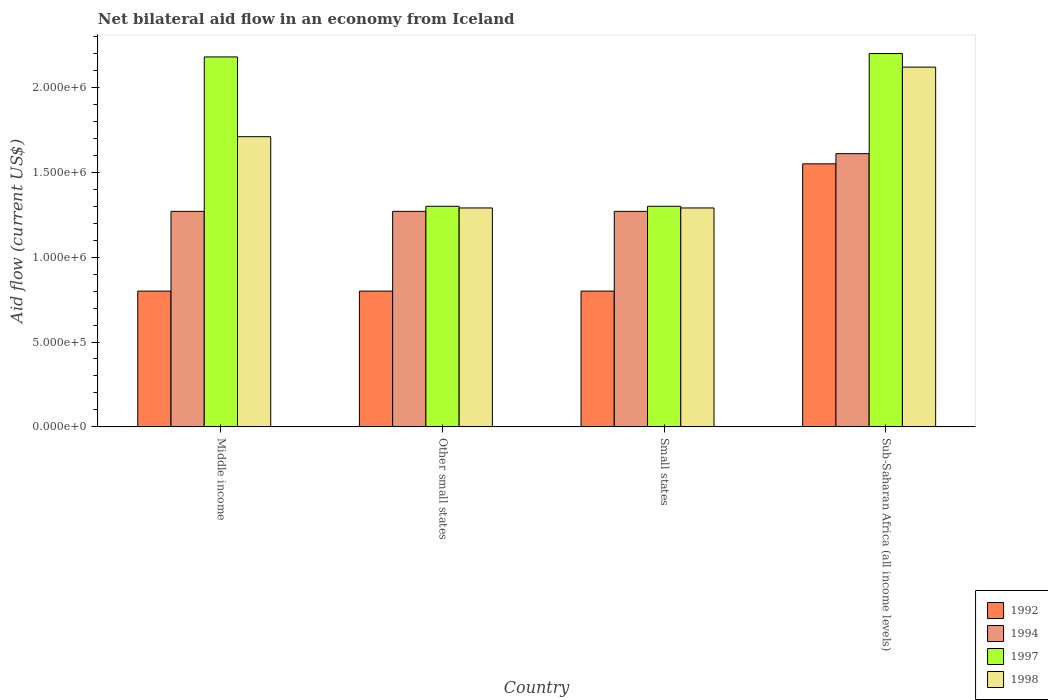How many groups of bars are there?
Give a very brief answer. 4. Are the number of bars per tick equal to the number of legend labels?
Provide a short and direct response. Yes. Are the number of bars on each tick of the X-axis equal?
Provide a succinct answer. Yes. What is the label of the 4th group of bars from the left?
Make the answer very short. Sub-Saharan Africa (all income levels). What is the net bilateral aid flow in 1994 in Small states?
Your response must be concise. 1.27e+06. Across all countries, what is the maximum net bilateral aid flow in 1994?
Your answer should be compact. 1.61e+06. Across all countries, what is the minimum net bilateral aid flow in 1997?
Provide a succinct answer. 1.30e+06. In which country was the net bilateral aid flow in 1998 maximum?
Ensure brevity in your answer.  Sub-Saharan Africa (all income levels). In which country was the net bilateral aid flow in 1994 minimum?
Offer a terse response. Middle income. What is the total net bilateral aid flow in 1994 in the graph?
Offer a very short reply. 5.42e+06. What is the difference between the net bilateral aid flow in 1994 in Middle income and that in Other small states?
Offer a terse response. 0. What is the difference between the net bilateral aid flow in 1998 in Other small states and the net bilateral aid flow in 1994 in Middle income?
Make the answer very short. 2.00e+04. What is the average net bilateral aid flow in 1992 per country?
Keep it short and to the point. 9.88e+05. What is the difference between the net bilateral aid flow of/in 1997 and net bilateral aid flow of/in 1998 in Small states?
Provide a short and direct response. 10000. What is the ratio of the net bilateral aid flow in 1994 in Middle income to that in Small states?
Provide a short and direct response. 1. What is the difference between the highest and the lowest net bilateral aid flow in 1998?
Your response must be concise. 8.30e+05. In how many countries, is the net bilateral aid flow in 1997 greater than the average net bilateral aid flow in 1997 taken over all countries?
Keep it short and to the point. 2. Is the sum of the net bilateral aid flow in 1998 in Small states and Sub-Saharan Africa (all income levels) greater than the maximum net bilateral aid flow in 1997 across all countries?
Offer a very short reply. Yes. What does the 4th bar from the right in Small states represents?
Your answer should be very brief. 1992. Is it the case that in every country, the sum of the net bilateral aid flow in 1997 and net bilateral aid flow in 1994 is greater than the net bilateral aid flow in 1998?
Provide a succinct answer. Yes. How many bars are there?
Keep it short and to the point. 16. Are all the bars in the graph horizontal?
Your answer should be compact. No. Does the graph contain grids?
Ensure brevity in your answer.  No. Where does the legend appear in the graph?
Your answer should be very brief. Bottom right. How are the legend labels stacked?
Provide a succinct answer. Vertical. What is the title of the graph?
Provide a short and direct response. Net bilateral aid flow in an economy from Iceland. What is the Aid flow (current US$) of 1992 in Middle income?
Make the answer very short. 8.00e+05. What is the Aid flow (current US$) of 1994 in Middle income?
Keep it short and to the point. 1.27e+06. What is the Aid flow (current US$) in 1997 in Middle income?
Keep it short and to the point. 2.18e+06. What is the Aid flow (current US$) of 1998 in Middle income?
Provide a short and direct response. 1.71e+06. What is the Aid flow (current US$) of 1992 in Other small states?
Provide a short and direct response. 8.00e+05. What is the Aid flow (current US$) in 1994 in Other small states?
Your response must be concise. 1.27e+06. What is the Aid flow (current US$) of 1997 in Other small states?
Give a very brief answer. 1.30e+06. What is the Aid flow (current US$) in 1998 in Other small states?
Make the answer very short. 1.29e+06. What is the Aid flow (current US$) in 1994 in Small states?
Your response must be concise. 1.27e+06. What is the Aid flow (current US$) of 1997 in Small states?
Give a very brief answer. 1.30e+06. What is the Aid flow (current US$) in 1998 in Small states?
Give a very brief answer. 1.29e+06. What is the Aid flow (current US$) of 1992 in Sub-Saharan Africa (all income levels)?
Your answer should be very brief. 1.55e+06. What is the Aid flow (current US$) of 1994 in Sub-Saharan Africa (all income levels)?
Make the answer very short. 1.61e+06. What is the Aid flow (current US$) in 1997 in Sub-Saharan Africa (all income levels)?
Offer a very short reply. 2.20e+06. What is the Aid flow (current US$) in 1998 in Sub-Saharan Africa (all income levels)?
Your response must be concise. 2.12e+06. Across all countries, what is the maximum Aid flow (current US$) of 1992?
Your answer should be compact. 1.55e+06. Across all countries, what is the maximum Aid flow (current US$) in 1994?
Provide a short and direct response. 1.61e+06. Across all countries, what is the maximum Aid flow (current US$) of 1997?
Your answer should be very brief. 2.20e+06. Across all countries, what is the maximum Aid flow (current US$) of 1998?
Keep it short and to the point. 2.12e+06. Across all countries, what is the minimum Aid flow (current US$) of 1992?
Offer a terse response. 8.00e+05. Across all countries, what is the minimum Aid flow (current US$) of 1994?
Provide a short and direct response. 1.27e+06. Across all countries, what is the minimum Aid flow (current US$) in 1997?
Provide a succinct answer. 1.30e+06. Across all countries, what is the minimum Aid flow (current US$) in 1998?
Your answer should be very brief. 1.29e+06. What is the total Aid flow (current US$) of 1992 in the graph?
Ensure brevity in your answer.  3.95e+06. What is the total Aid flow (current US$) in 1994 in the graph?
Provide a succinct answer. 5.42e+06. What is the total Aid flow (current US$) in 1997 in the graph?
Provide a succinct answer. 6.98e+06. What is the total Aid flow (current US$) of 1998 in the graph?
Offer a terse response. 6.41e+06. What is the difference between the Aid flow (current US$) of 1992 in Middle income and that in Other small states?
Offer a terse response. 0. What is the difference between the Aid flow (current US$) of 1994 in Middle income and that in Other small states?
Your answer should be compact. 0. What is the difference between the Aid flow (current US$) of 1997 in Middle income and that in Other small states?
Ensure brevity in your answer.  8.80e+05. What is the difference between the Aid flow (current US$) of 1994 in Middle income and that in Small states?
Provide a short and direct response. 0. What is the difference between the Aid flow (current US$) in 1997 in Middle income and that in Small states?
Your response must be concise. 8.80e+05. What is the difference between the Aid flow (current US$) in 1998 in Middle income and that in Small states?
Ensure brevity in your answer.  4.20e+05. What is the difference between the Aid flow (current US$) in 1992 in Middle income and that in Sub-Saharan Africa (all income levels)?
Ensure brevity in your answer.  -7.50e+05. What is the difference between the Aid flow (current US$) of 1997 in Middle income and that in Sub-Saharan Africa (all income levels)?
Offer a very short reply. -2.00e+04. What is the difference between the Aid flow (current US$) in 1998 in Middle income and that in Sub-Saharan Africa (all income levels)?
Offer a terse response. -4.10e+05. What is the difference between the Aid flow (current US$) in 1992 in Other small states and that in Small states?
Your answer should be compact. 0. What is the difference between the Aid flow (current US$) of 1994 in Other small states and that in Small states?
Keep it short and to the point. 0. What is the difference between the Aid flow (current US$) of 1998 in Other small states and that in Small states?
Make the answer very short. 0. What is the difference between the Aid flow (current US$) of 1992 in Other small states and that in Sub-Saharan Africa (all income levels)?
Provide a short and direct response. -7.50e+05. What is the difference between the Aid flow (current US$) in 1997 in Other small states and that in Sub-Saharan Africa (all income levels)?
Your answer should be compact. -9.00e+05. What is the difference between the Aid flow (current US$) in 1998 in Other small states and that in Sub-Saharan Africa (all income levels)?
Give a very brief answer. -8.30e+05. What is the difference between the Aid flow (current US$) of 1992 in Small states and that in Sub-Saharan Africa (all income levels)?
Give a very brief answer. -7.50e+05. What is the difference between the Aid flow (current US$) of 1994 in Small states and that in Sub-Saharan Africa (all income levels)?
Provide a succinct answer. -3.40e+05. What is the difference between the Aid flow (current US$) of 1997 in Small states and that in Sub-Saharan Africa (all income levels)?
Provide a succinct answer. -9.00e+05. What is the difference between the Aid flow (current US$) in 1998 in Small states and that in Sub-Saharan Africa (all income levels)?
Your answer should be very brief. -8.30e+05. What is the difference between the Aid flow (current US$) in 1992 in Middle income and the Aid flow (current US$) in 1994 in Other small states?
Ensure brevity in your answer.  -4.70e+05. What is the difference between the Aid flow (current US$) of 1992 in Middle income and the Aid flow (current US$) of 1997 in Other small states?
Ensure brevity in your answer.  -5.00e+05. What is the difference between the Aid flow (current US$) of 1992 in Middle income and the Aid flow (current US$) of 1998 in Other small states?
Give a very brief answer. -4.90e+05. What is the difference between the Aid flow (current US$) in 1994 in Middle income and the Aid flow (current US$) in 1998 in Other small states?
Provide a succinct answer. -2.00e+04. What is the difference between the Aid flow (current US$) in 1997 in Middle income and the Aid flow (current US$) in 1998 in Other small states?
Keep it short and to the point. 8.90e+05. What is the difference between the Aid flow (current US$) in 1992 in Middle income and the Aid flow (current US$) in 1994 in Small states?
Give a very brief answer. -4.70e+05. What is the difference between the Aid flow (current US$) of 1992 in Middle income and the Aid flow (current US$) of 1997 in Small states?
Keep it short and to the point. -5.00e+05. What is the difference between the Aid flow (current US$) of 1992 in Middle income and the Aid flow (current US$) of 1998 in Small states?
Offer a very short reply. -4.90e+05. What is the difference between the Aid flow (current US$) of 1997 in Middle income and the Aid flow (current US$) of 1998 in Small states?
Your response must be concise. 8.90e+05. What is the difference between the Aid flow (current US$) in 1992 in Middle income and the Aid flow (current US$) in 1994 in Sub-Saharan Africa (all income levels)?
Provide a short and direct response. -8.10e+05. What is the difference between the Aid flow (current US$) in 1992 in Middle income and the Aid flow (current US$) in 1997 in Sub-Saharan Africa (all income levels)?
Your answer should be compact. -1.40e+06. What is the difference between the Aid flow (current US$) of 1992 in Middle income and the Aid flow (current US$) of 1998 in Sub-Saharan Africa (all income levels)?
Ensure brevity in your answer.  -1.32e+06. What is the difference between the Aid flow (current US$) in 1994 in Middle income and the Aid flow (current US$) in 1997 in Sub-Saharan Africa (all income levels)?
Keep it short and to the point. -9.30e+05. What is the difference between the Aid flow (current US$) of 1994 in Middle income and the Aid flow (current US$) of 1998 in Sub-Saharan Africa (all income levels)?
Provide a short and direct response. -8.50e+05. What is the difference between the Aid flow (current US$) of 1992 in Other small states and the Aid flow (current US$) of 1994 in Small states?
Your answer should be compact. -4.70e+05. What is the difference between the Aid flow (current US$) of 1992 in Other small states and the Aid flow (current US$) of 1997 in Small states?
Your response must be concise. -5.00e+05. What is the difference between the Aid flow (current US$) in 1992 in Other small states and the Aid flow (current US$) in 1998 in Small states?
Keep it short and to the point. -4.90e+05. What is the difference between the Aid flow (current US$) of 1994 in Other small states and the Aid flow (current US$) of 1998 in Small states?
Keep it short and to the point. -2.00e+04. What is the difference between the Aid flow (current US$) of 1992 in Other small states and the Aid flow (current US$) of 1994 in Sub-Saharan Africa (all income levels)?
Your answer should be very brief. -8.10e+05. What is the difference between the Aid flow (current US$) in 1992 in Other small states and the Aid flow (current US$) in 1997 in Sub-Saharan Africa (all income levels)?
Your answer should be very brief. -1.40e+06. What is the difference between the Aid flow (current US$) of 1992 in Other small states and the Aid flow (current US$) of 1998 in Sub-Saharan Africa (all income levels)?
Provide a succinct answer. -1.32e+06. What is the difference between the Aid flow (current US$) in 1994 in Other small states and the Aid flow (current US$) in 1997 in Sub-Saharan Africa (all income levels)?
Make the answer very short. -9.30e+05. What is the difference between the Aid flow (current US$) of 1994 in Other small states and the Aid flow (current US$) of 1998 in Sub-Saharan Africa (all income levels)?
Provide a short and direct response. -8.50e+05. What is the difference between the Aid flow (current US$) in 1997 in Other small states and the Aid flow (current US$) in 1998 in Sub-Saharan Africa (all income levels)?
Your answer should be compact. -8.20e+05. What is the difference between the Aid flow (current US$) in 1992 in Small states and the Aid flow (current US$) in 1994 in Sub-Saharan Africa (all income levels)?
Offer a terse response. -8.10e+05. What is the difference between the Aid flow (current US$) of 1992 in Small states and the Aid flow (current US$) of 1997 in Sub-Saharan Africa (all income levels)?
Ensure brevity in your answer.  -1.40e+06. What is the difference between the Aid flow (current US$) of 1992 in Small states and the Aid flow (current US$) of 1998 in Sub-Saharan Africa (all income levels)?
Your answer should be very brief. -1.32e+06. What is the difference between the Aid flow (current US$) in 1994 in Small states and the Aid flow (current US$) in 1997 in Sub-Saharan Africa (all income levels)?
Your answer should be very brief. -9.30e+05. What is the difference between the Aid flow (current US$) in 1994 in Small states and the Aid flow (current US$) in 1998 in Sub-Saharan Africa (all income levels)?
Your answer should be very brief. -8.50e+05. What is the difference between the Aid flow (current US$) of 1997 in Small states and the Aid flow (current US$) of 1998 in Sub-Saharan Africa (all income levels)?
Your response must be concise. -8.20e+05. What is the average Aid flow (current US$) of 1992 per country?
Your answer should be compact. 9.88e+05. What is the average Aid flow (current US$) in 1994 per country?
Your response must be concise. 1.36e+06. What is the average Aid flow (current US$) in 1997 per country?
Your response must be concise. 1.74e+06. What is the average Aid flow (current US$) in 1998 per country?
Make the answer very short. 1.60e+06. What is the difference between the Aid flow (current US$) in 1992 and Aid flow (current US$) in 1994 in Middle income?
Give a very brief answer. -4.70e+05. What is the difference between the Aid flow (current US$) of 1992 and Aid flow (current US$) of 1997 in Middle income?
Offer a terse response. -1.38e+06. What is the difference between the Aid flow (current US$) of 1992 and Aid flow (current US$) of 1998 in Middle income?
Your answer should be compact. -9.10e+05. What is the difference between the Aid flow (current US$) in 1994 and Aid flow (current US$) in 1997 in Middle income?
Your answer should be compact. -9.10e+05. What is the difference between the Aid flow (current US$) of 1994 and Aid flow (current US$) of 1998 in Middle income?
Provide a succinct answer. -4.40e+05. What is the difference between the Aid flow (current US$) of 1992 and Aid flow (current US$) of 1994 in Other small states?
Offer a very short reply. -4.70e+05. What is the difference between the Aid flow (current US$) in 1992 and Aid flow (current US$) in 1997 in Other small states?
Make the answer very short. -5.00e+05. What is the difference between the Aid flow (current US$) of 1992 and Aid flow (current US$) of 1998 in Other small states?
Provide a succinct answer. -4.90e+05. What is the difference between the Aid flow (current US$) in 1994 and Aid flow (current US$) in 1998 in Other small states?
Provide a short and direct response. -2.00e+04. What is the difference between the Aid flow (current US$) in 1992 and Aid flow (current US$) in 1994 in Small states?
Make the answer very short. -4.70e+05. What is the difference between the Aid flow (current US$) of 1992 and Aid flow (current US$) of 1997 in Small states?
Keep it short and to the point. -5.00e+05. What is the difference between the Aid flow (current US$) in 1992 and Aid flow (current US$) in 1998 in Small states?
Give a very brief answer. -4.90e+05. What is the difference between the Aid flow (current US$) of 1994 and Aid flow (current US$) of 1997 in Small states?
Make the answer very short. -3.00e+04. What is the difference between the Aid flow (current US$) of 1997 and Aid flow (current US$) of 1998 in Small states?
Offer a very short reply. 10000. What is the difference between the Aid flow (current US$) in 1992 and Aid flow (current US$) in 1994 in Sub-Saharan Africa (all income levels)?
Ensure brevity in your answer.  -6.00e+04. What is the difference between the Aid flow (current US$) in 1992 and Aid flow (current US$) in 1997 in Sub-Saharan Africa (all income levels)?
Keep it short and to the point. -6.50e+05. What is the difference between the Aid flow (current US$) in 1992 and Aid flow (current US$) in 1998 in Sub-Saharan Africa (all income levels)?
Your response must be concise. -5.70e+05. What is the difference between the Aid flow (current US$) in 1994 and Aid flow (current US$) in 1997 in Sub-Saharan Africa (all income levels)?
Offer a terse response. -5.90e+05. What is the difference between the Aid flow (current US$) of 1994 and Aid flow (current US$) of 1998 in Sub-Saharan Africa (all income levels)?
Your answer should be very brief. -5.10e+05. What is the difference between the Aid flow (current US$) in 1997 and Aid flow (current US$) in 1998 in Sub-Saharan Africa (all income levels)?
Your answer should be compact. 8.00e+04. What is the ratio of the Aid flow (current US$) in 1997 in Middle income to that in Other small states?
Provide a short and direct response. 1.68. What is the ratio of the Aid flow (current US$) in 1998 in Middle income to that in Other small states?
Provide a short and direct response. 1.33. What is the ratio of the Aid flow (current US$) of 1992 in Middle income to that in Small states?
Provide a succinct answer. 1. What is the ratio of the Aid flow (current US$) in 1994 in Middle income to that in Small states?
Ensure brevity in your answer.  1. What is the ratio of the Aid flow (current US$) in 1997 in Middle income to that in Small states?
Offer a very short reply. 1.68. What is the ratio of the Aid flow (current US$) in 1998 in Middle income to that in Small states?
Ensure brevity in your answer.  1.33. What is the ratio of the Aid flow (current US$) in 1992 in Middle income to that in Sub-Saharan Africa (all income levels)?
Keep it short and to the point. 0.52. What is the ratio of the Aid flow (current US$) of 1994 in Middle income to that in Sub-Saharan Africa (all income levels)?
Ensure brevity in your answer.  0.79. What is the ratio of the Aid flow (current US$) of 1997 in Middle income to that in Sub-Saharan Africa (all income levels)?
Your answer should be compact. 0.99. What is the ratio of the Aid flow (current US$) in 1998 in Middle income to that in Sub-Saharan Africa (all income levels)?
Your answer should be compact. 0.81. What is the ratio of the Aid flow (current US$) of 1994 in Other small states to that in Small states?
Provide a short and direct response. 1. What is the ratio of the Aid flow (current US$) of 1997 in Other small states to that in Small states?
Ensure brevity in your answer.  1. What is the ratio of the Aid flow (current US$) of 1998 in Other small states to that in Small states?
Provide a short and direct response. 1. What is the ratio of the Aid flow (current US$) in 1992 in Other small states to that in Sub-Saharan Africa (all income levels)?
Make the answer very short. 0.52. What is the ratio of the Aid flow (current US$) in 1994 in Other small states to that in Sub-Saharan Africa (all income levels)?
Offer a very short reply. 0.79. What is the ratio of the Aid flow (current US$) of 1997 in Other small states to that in Sub-Saharan Africa (all income levels)?
Ensure brevity in your answer.  0.59. What is the ratio of the Aid flow (current US$) in 1998 in Other small states to that in Sub-Saharan Africa (all income levels)?
Your response must be concise. 0.61. What is the ratio of the Aid flow (current US$) of 1992 in Small states to that in Sub-Saharan Africa (all income levels)?
Offer a terse response. 0.52. What is the ratio of the Aid flow (current US$) in 1994 in Small states to that in Sub-Saharan Africa (all income levels)?
Make the answer very short. 0.79. What is the ratio of the Aid flow (current US$) of 1997 in Small states to that in Sub-Saharan Africa (all income levels)?
Provide a succinct answer. 0.59. What is the ratio of the Aid flow (current US$) in 1998 in Small states to that in Sub-Saharan Africa (all income levels)?
Your answer should be very brief. 0.61. What is the difference between the highest and the second highest Aid flow (current US$) of 1992?
Provide a succinct answer. 7.50e+05. What is the difference between the highest and the lowest Aid flow (current US$) in 1992?
Your answer should be compact. 7.50e+05. What is the difference between the highest and the lowest Aid flow (current US$) in 1998?
Your answer should be very brief. 8.30e+05. 